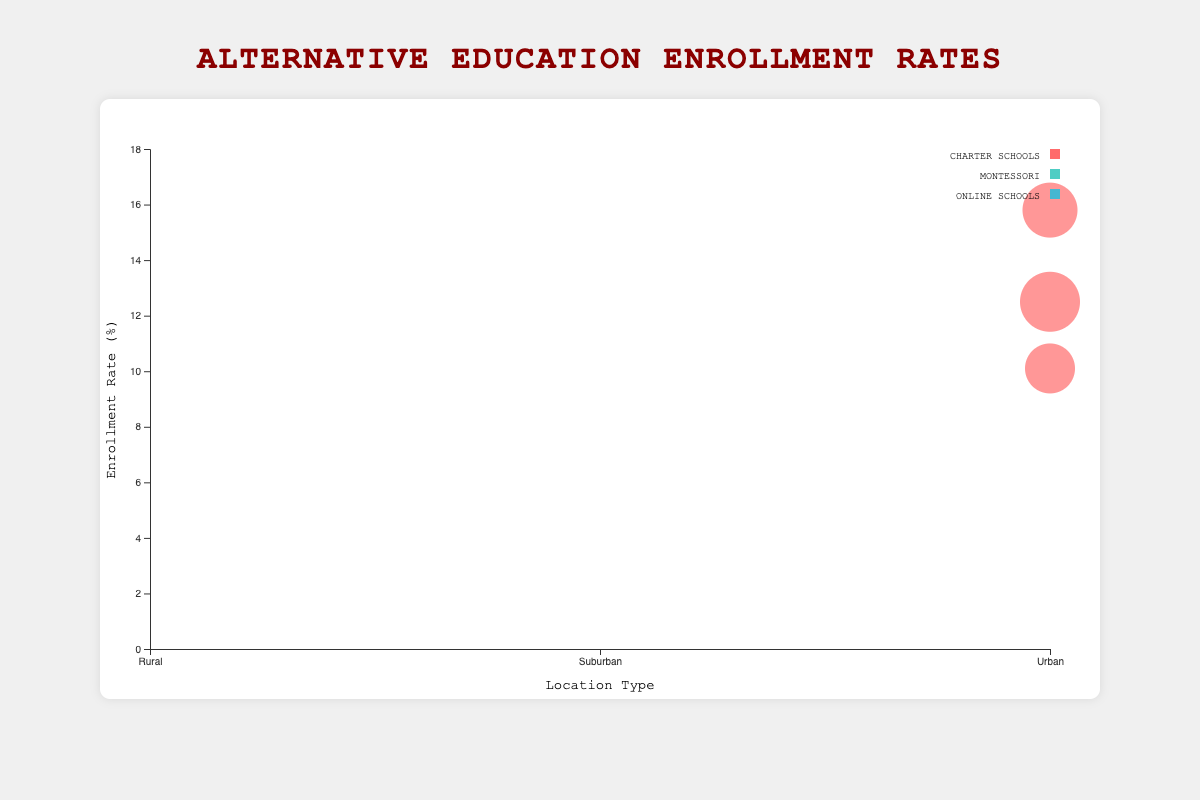**Basic Question 1**: What is the title of the figure? The title is located at the top center of the figure and is usually in a larger or bold font for visibility. The title directly describes what the chart is about.
Answer: Alternative Education Enrollment Rates **Basic Question 2**: What does the x-axis represent? The labels on the x-axis indicate it represents different location types, which are Urban, Suburban, and Rural. This axis is positioned horizontally at the bottom of the figure.
Answer: Location Type **Compositional Question**: What is the average enrollment rate for Charter Schools in Urban areas? To find the average enrollment rate for Charter Schools in Urban areas, we'll sum the enrollment rates for New York City, Los Angeles, and Chicago, then divide by the number of cities. The rates are 12.5, 15.8, and 10.1. (12.5 + 15.8 + 10.1) / 3 = 12.8
Answer: 12.8 **Comparison Question 1**: Which Urban area has the highest enrollment rate for Montessori schools? By comparing the bubbles in the Urban section for Montessori schools, we see their enrollment rates. San Francisco has an enrollment rate of 7.3%, and Seattle has 6.8%. Therefore, San Francisco has the highest rate.
Answer: San Francisco **Comparison Question 2**: Which education model has the highest bubble size in Suburban areas? We compare the bubble sizes for each education model in Suburban areas. For Charter Schools, Naperville, IL has a bubble size of 2300. For Montessori, Palo Alto, CA has 1600. For Online Schools, Plano, TX has 2100. The largest is for Charter Schools at 2300.
Answer: Charter Schools **Chart-Type Specific Question**: Among all entities, which one has the largest bubble size? The size of the bubble represents the entity's bubble size, so we look at all bubbles in the chart. New York City for Charter Schools has the largest bubble size of 5000.
Answer: New York City **Comparison Question 3**: How does the enrollment rate for rural Montessori schools compare to suburban Montessori schools? For rural Montessori schools, the rates are 2.3% and 3.1%, averaging (2.3 + 3.1) / 2 = 2.7%. Suburban rates are 9.1% and 8.4%, averaging (9.1 + 8.4) / 2 = 8.75%. Rural rates are significantly lower than suburban rates.
Answer: Rural rates are lower **Basic Question 3**: What color represents Montessori schools in the figure? In the legend, colors are associated with different education models. Montessori schools are represented by the color that matches their bubbles. Montessori schools are indicated by a blue-green hue.
Answer: Blue-green **Chart-Type Specific Question 2**: What does the size of each bubble represent? The size, or area, of each bubble correlates to another variable, in this case, the bubble size attribute from the data which indicates possibly the number of students or some measure relevant to that entity.
Answer: Bubble size attribute, likely student count 